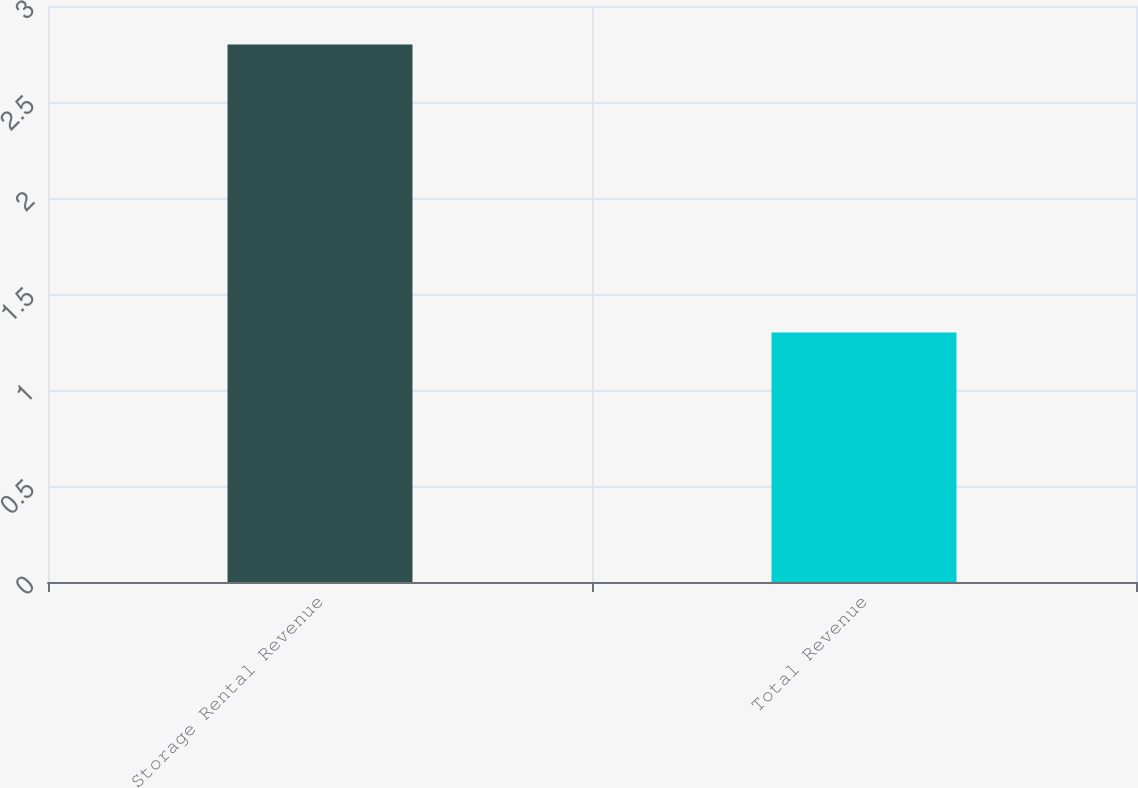Convert chart. <chart><loc_0><loc_0><loc_500><loc_500><bar_chart><fcel>Storage Rental Revenue<fcel>Total Revenue<nl><fcel>2.8<fcel>1.3<nl></chart> 